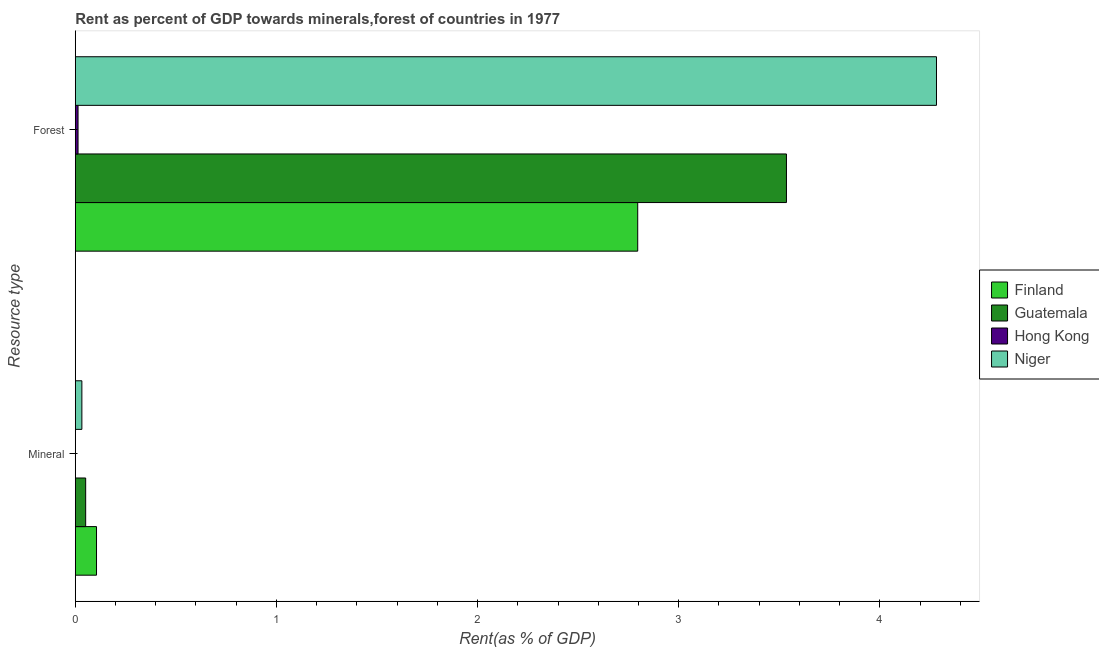How many different coloured bars are there?
Your answer should be very brief. 4. How many groups of bars are there?
Your answer should be very brief. 2. Are the number of bars per tick equal to the number of legend labels?
Provide a succinct answer. Yes. Are the number of bars on each tick of the Y-axis equal?
Give a very brief answer. Yes. How many bars are there on the 2nd tick from the top?
Ensure brevity in your answer.  4. How many bars are there on the 1st tick from the bottom?
Make the answer very short. 4. What is the label of the 1st group of bars from the top?
Your answer should be compact. Forest. What is the mineral rent in Niger?
Keep it short and to the point. 0.03. Across all countries, what is the maximum mineral rent?
Provide a succinct answer. 0.11. Across all countries, what is the minimum mineral rent?
Make the answer very short. 0. In which country was the forest rent maximum?
Keep it short and to the point. Niger. In which country was the forest rent minimum?
Provide a short and direct response. Hong Kong. What is the total forest rent in the graph?
Offer a terse response. 10.63. What is the difference between the mineral rent in Guatemala and that in Niger?
Your answer should be very brief. 0.02. What is the difference between the mineral rent in Niger and the forest rent in Finland?
Keep it short and to the point. -2.76. What is the average mineral rent per country?
Provide a succinct answer. 0.05. What is the difference between the forest rent and mineral rent in Niger?
Make the answer very short. 4.25. What is the ratio of the mineral rent in Guatemala to that in Finland?
Provide a succinct answer. 0.49. Is the forest rent in Hong Kong less than that in Niger?
Provide a succinct answer. Yes. What does the 3rd bar from the top in Mineral represents?
Make the answer very short. Guatemala. What does the 2nd bar from the bottom in Mineral represents?
Make the answer very short. Guatemala. Does the graph contain grids?
Your answer should be very brief. No. Where does the legend appear in the graph?
Ensure brevity in your answer.  Center right. What is the title of the graph?
Provide a succinct answer. Rent as percent of GDP towards minerals,forest of countries in 1977. What is the label or title of the X-axis?
Your response must be concise. Rent(as % of GDP). What is the label or title of the Y-axis?
Your answer should be compact. Resource type. What is the Rent(as % of GDP) of Finland in Mineral?
Make the answer very short. 0.11. What is the Rent(as % of GDP) of Guatemala in Mineral?
Keep it short and to the point. 0.05. What is the Rent(as % of GDP) of Hong Kong in Mineral?
Your answer should be compact. 0. What is the Rent(as % of GDP) in Niger in Mineral?
Offer a very short reply. 0.03. What is the Rent(as % of GDP) in Finland in Forest?
Your answer should be very brief. 2.8. What is the Rent(as % of GDP) in Guatemala in Forest?
Provide a short and direct response. 3.54. What is the Rent(as % of GDP) of Hong Kong in Forest?
Your response must be concise. 0.01. What is the Rent(as % of GDP) in Niger in Forest?
Your answer should be compact. 4.28. Across all Resource type, what is the maximum Rent(as % of GDP) of Finland?
Keep it short and to the point. 2.8. Across all Resource type, what is the maximum Rent(as % of GDP) in Guatemala?
Offer a very short reply. 3.54. Across all Resource type, what is the maximum Rent(as % of GDP) of Hong Kong?
Provide a short and direct response. 0.01. Across all Resource type, what is the maximum Rent(as % of GDP) in Niger?
Ensure brevity in your answer.  4.28. Across all Resource type, what is the minimum Rent(as % of GDP) of Finland?
Offer a terse response. 0.11. Across all Resource type, what is the minimum Rent(as % of GDP) of Guatemala?
Offer a very short reply. 0.05. Across all Resource type, what is the minimum Rent(as % of GDP) in Hong Kong?
Your answer should be very brief. 0. Across all Resource type, what is the minimum Rent(as % of GDP) of Niger?
Keep it short and to the point. 0.03. What is the total Rent(as % of GDP) of Finland in the graph?
Provide a short and direct response. 2.9. What is the total Rent(as % of GDP) of Guatemala in the graph?
Offer a very short reply. 3.59. What is the total Rent(as % of GDP) of Hong Kong in the graph?
Give a very brief answer. 0.01. What is the total Rent(as % of GDP) of Niger in the graph?
Provide a succinct answer. 4.31. What is the difference between the Rent(as % of GDP) in Finland in Mineral and that in Forest?
Offer a terse response. -2.69. What is the difference between the Rent(as % of GDP) in Guatemala in Mineral and that in Forest?
Ensure brevity in your answer.  -3.48. What is the difference between the Rent(as % of GDP) in Hong Kong in Mineral and that in Forest?
Provide a succinct answer. -0.01. What is the difference between the Rent(as % of GDP) in Niger in Mineral and that in Forest?
Your response must be concise. -4.25. What is the difference between the Rent(as % of GDP) of Finland in Mineral and the Rent(as % of GDP) of Guatemala in Forest?
Your answer should be very brief. -3.43. What is the difference between the Rent(as % of GDP) in Finland in Mineral and the Rent(as % of GDP) in Hong Kong in Forest?
Provide a succinct answer. 0.09. What is the difference between the Rent(as % of GDP) of Finland in Mineral and the Rent(as % of GDP) of Niger in Forest?
Your response must be concise. -4.18. What is the difference between the Rent(as % of GDP) of Guatemala in Mineral and the Rent(as % of GDP) of Hong Kong in Forest?
Your response must be concise. 0.04. What is the difference between the Rent(as % of GDP) of Guatemala in Mineral and the Rent(as % of GDP) of Niger in Forest?
Provide a succinct answer. -4.23. What is the difference between the Rent(as % of GDP) in Hong Kong in Mineral and the Rent(as % of GDP) in Niger in Forest?
Provide a succinct answer. -4.28. What is the average Rent(as % of GDP) of Finland per Resource type?
Give a very brief answer. 1.45. What is the average Rent(as % of GDP) in Guatemala per Resource type?
Your answer should be very brief. 1.79. What is the average Rent(as % of GDP) of Hong Kong per Resource type?
Your response must be concise. 0.01. What is the average Rent(as % of GDP) of Niger per Resource type?
Provide a succinct answer. 2.16. What is the difference between the Rent(as % of GDP) in Finland and Rent(as % of GDP) in Guatemala in Mineral?
Keep it short and to the point. 0.05. What is the difference between the Rent(as % of GDP) in Finland and Rent(as % of GDP) in Hong Kong in Mineral?
Offer a very short reply. 0.1. What is the difference between the Rent(as % of GDP) in Finland and Rent(as % of GDP) in Niger in Mineral?
Your answer should be compact. 0.07. What is the difference between the Rent(as % of GDP) in Guatemala and Rent(as % of GDP) in Hong Kong in Mineral?
Provide a succinct answer. 0.05. What is the difference between the Rent(as % of GDP) of Guatemala and Rent(as % of GDP) of Niger in Mineral?
Provide a succinct answer. 0.02. What is the difference between the Rent(as % of GDP) of Hong Kong and Rent(as % of GDP) of Niger in Mineral?
Provide a short and direct response. -0.03. What is the difference between the Rent(as % of GDP) of Finland and Rent(as % of GDP) of Guatemala in Forest?
Make the answer very short. -0.74. What is the difference between the Rent(as % of GDP) in Finland and Rent(as % of GDP) in Hong Kong in Forest?
Ensure brevity in your answer.  2.78. What is the difference between the Rent(as % of GDP) in Finland and Rent(as % of GDP) in Niger in Forest?
Give a very brief answer. -1.49. What is the difference between the Rent(as % of GDP) in Guatemala and Rent(as % of GDP) in Hong Kong in Forest?
Provide a short and direct response. 3.52. What is the difference between the Rent(as % of GDP) in Guatemala and Rent(as % of GDP) in Niger in Forest?
Your answer should be very brief. -0.75. What is the difference between the Rent(as % of GDP) of Hong Kong and Rent(as % of GDP) of Niger in Forest?
Provide a short and direct response. -4.27. What is the ratio of the Rent(as % of GDP) of Finland in Mineral to that in Forest?
Offer a terse response. 0.04. What is the ratio of the Rent(as % of GDP) of Guatemala in Mineral to that in Forest?
Offer a very short reply. 0.01. What is the ratio of the Rent(as % of GDP) of Hong Kong in Mineral to that in Forest?
Your answer should be compact. 0.06. What is the ratio of the Rent(as % of GDP) of Niger in Mineral to that in Forest?
Offer a terse response. 0.01. What is the difference between the highest and the second highest Rent(as % of GDP) in Finland?
Provide a short and direct response. 2.69. What is the difference between the highest and the second highest Rent(as % of GDP) of Guatemala?
Your answer should be very brief. 3.48. What is the difference between the highest and the second highest Rent(as % of GDP) of Hong Kong?
Your answer should be very brief. 0.01. What is the difference between the highest and the second highest Rent(as % of GDP) of Niger?
Provide a short and direct response. 4.25. What is the difference between the highest and the lowest Rent(as % of GDP) in Finland?
Provide a succinct answer. 2.69. What is the difference between the highest and the lowest Rent(as % of GDP) of Guatemala?
Give a very brief answer. 3.48. What is the difference between the highest and the lowest Rent(as % of GDP) of Hong Kong?
Your response must be concise. 0.01. What is the difference between the highest and the lowest Rent(as % of GDP) in Niger?
Offer a very short reply. 4.25. 